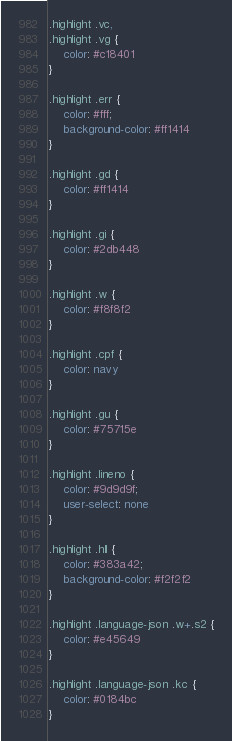Convert code to text. <code><loc_0><loc_0><loc_500><loc_500><_CSS_>.highlight .vc,
.highlight .vg {
    color: #c18401
}

.highlight .err {
    color: #fff;
    background-color: #ff1414
}

.highlight .gd {
    color: #ff1414
}

.highlight .gi {
    color: #2db448
}

.highlight .w {
    color: #f8f8f2
}

.highlight .cpf {
    color: navy
}

.highlight .gu {
    color: #75715e
}

.highlight .lineno {
    color: #9d9d9f;
    user-select: none
}

.highlight .hll {
    color: #383a42;
    background-color: #f2f2f2
}

.highlight .language-json .w+.s2 {
    color: #e45649
}

.highlight .language-json .kc {
    color: #0184bc
}</code> 